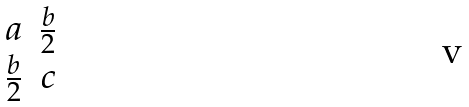<formula> <loc_0><loc_0><loc_500><loc_500>\begin{matrix} a & \frac { b } { 2 } \\ \frac { b } { 2 } & c \end{matrix}</formula> 